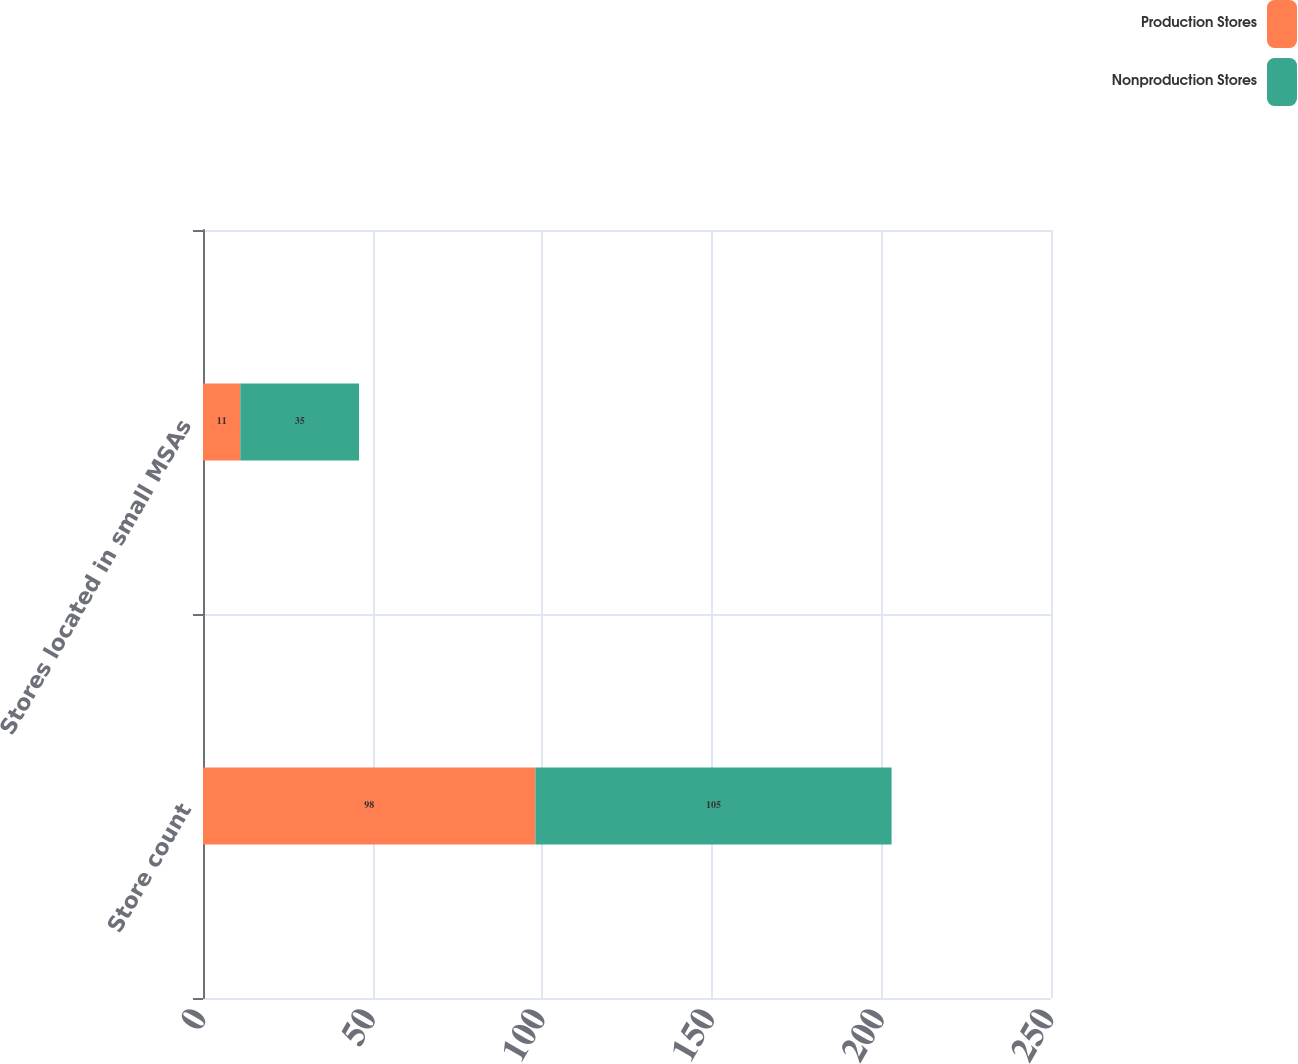<chart> <loc_0><loc_0><loc_500><loc_500><stacked_bar_chart><ecel><fcel>Store count<fcel>Stores located in small MSAs<nl><fcel>Production Stores<fcel>98<fcel>11<nl><fcel>Nonproduction Stores<fcel>105<fcel>35<nl></chart> 